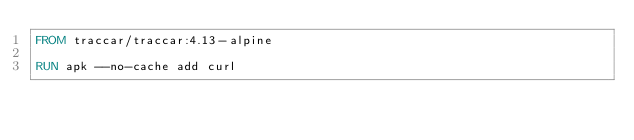<code> <loc_0><loc_0><loc_500><loc_500><_Dockerfile_>FROM traccar/traccar:4.13-alpine

RUN apk --no-cache add curl
</code> 